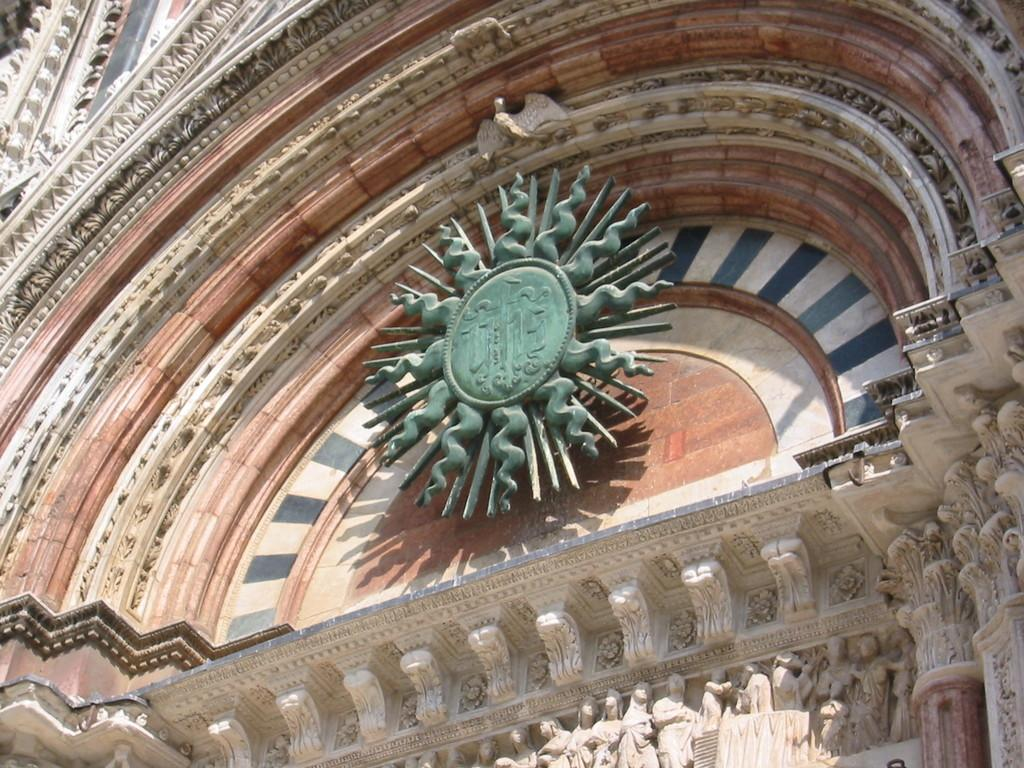What type of artwork is featured in the image? There is a group of sculptures in the image. Where are the statues located in the image? The statues are on a building in the image. What channel is the minister representing in the image? There is no minister or channel present in the image; it features a group of sculptures and statues on a building. 